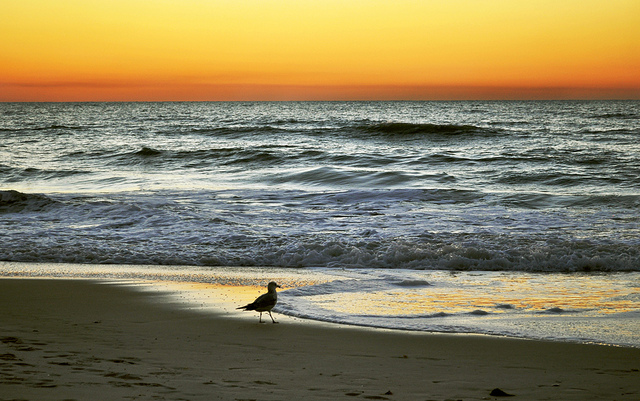<image>Why is the horizon curved? The reason why the horizon is curved is unknown. It can be due to the shape of the earth or light refraction. Why is the horizon curved? The horizon appears curved due to the shape of the Earth. 